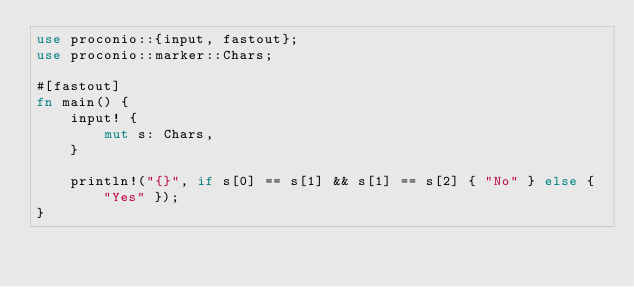Convert code to text. <code><loc_0><loc_0><loc_500><loc_500><_Rust_>use proconio::{input, fastout};
use proconio::marker::Chars;

#[fastout]
fn main() {
    input! {
        mut s: Chars,
    }

    println!("{}", if s[0] == s[1] && s[1] == s[2] { "No" } else { "Yes" });
}
</code> 